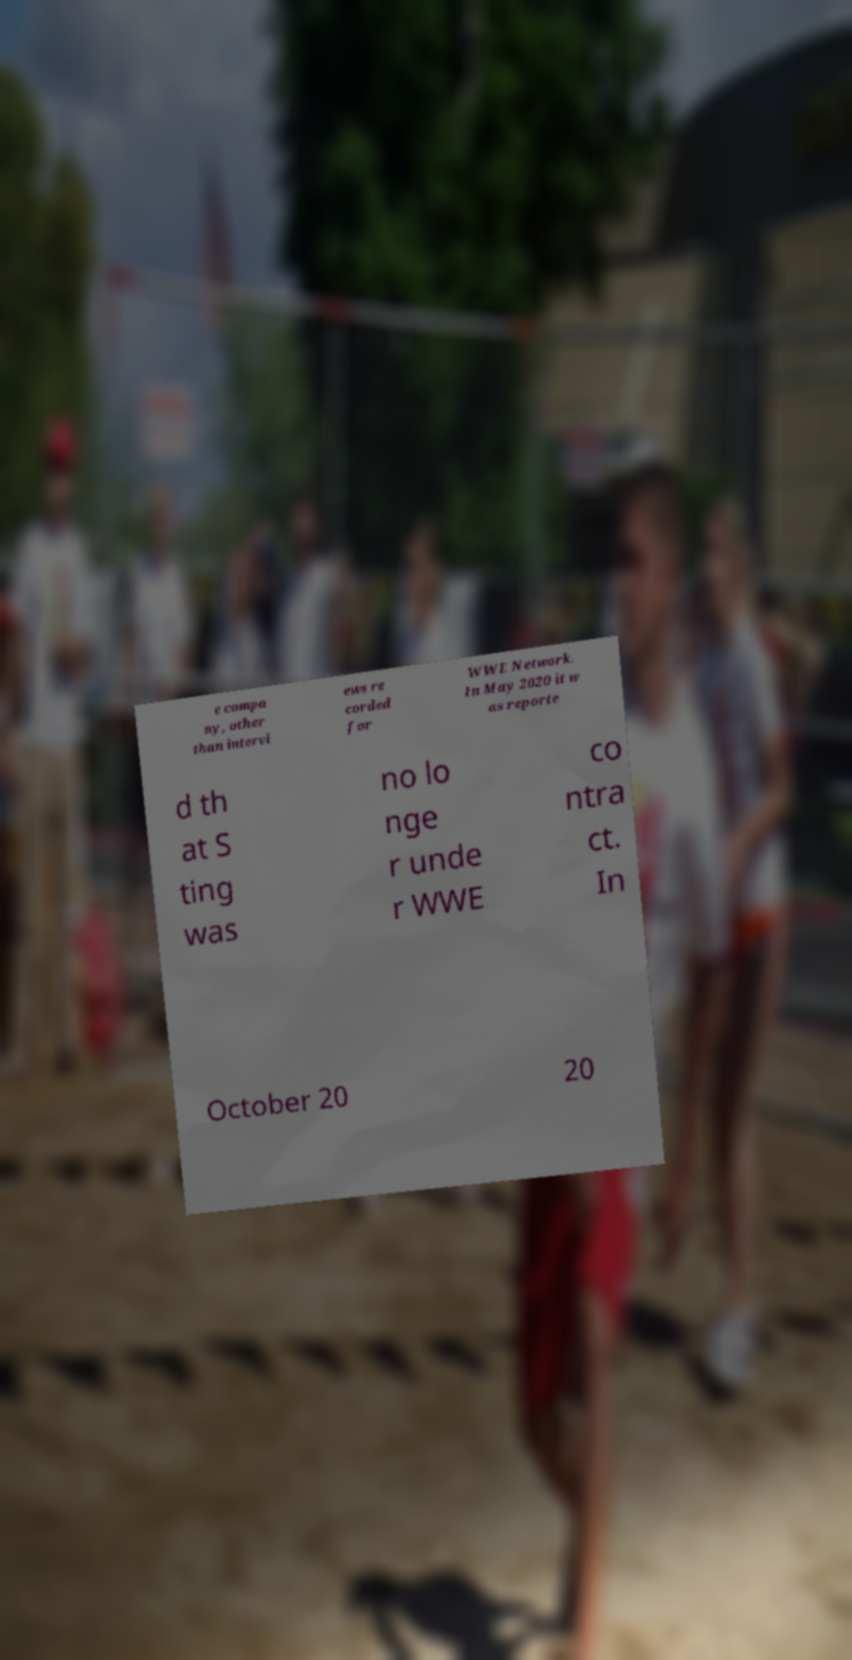Please read and relay the text visible in this image. What does it say? e compa ny, other than intervi ews re corded for WWE Network. In May 2020 it w as reporte d th at S ting was no lo nge r unde r WWE co ntra ct. In October 20 20 